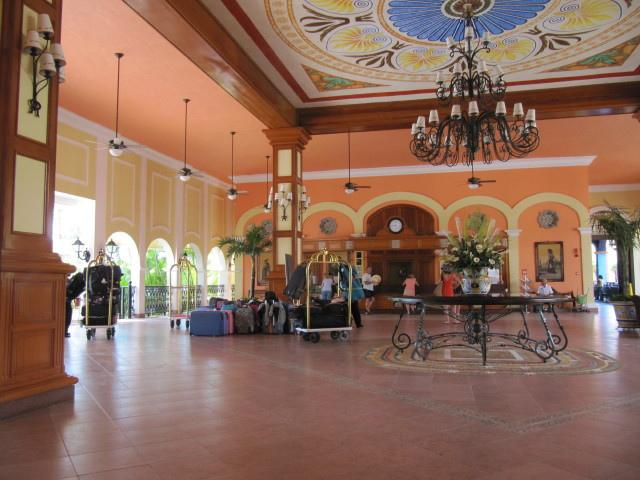What staff member is responsible for pushing the suitcase carts? Please explain your reasoning. bellhop. The suitcases were put on the carts by bellhops that work at the hotel and assist with luggage. 